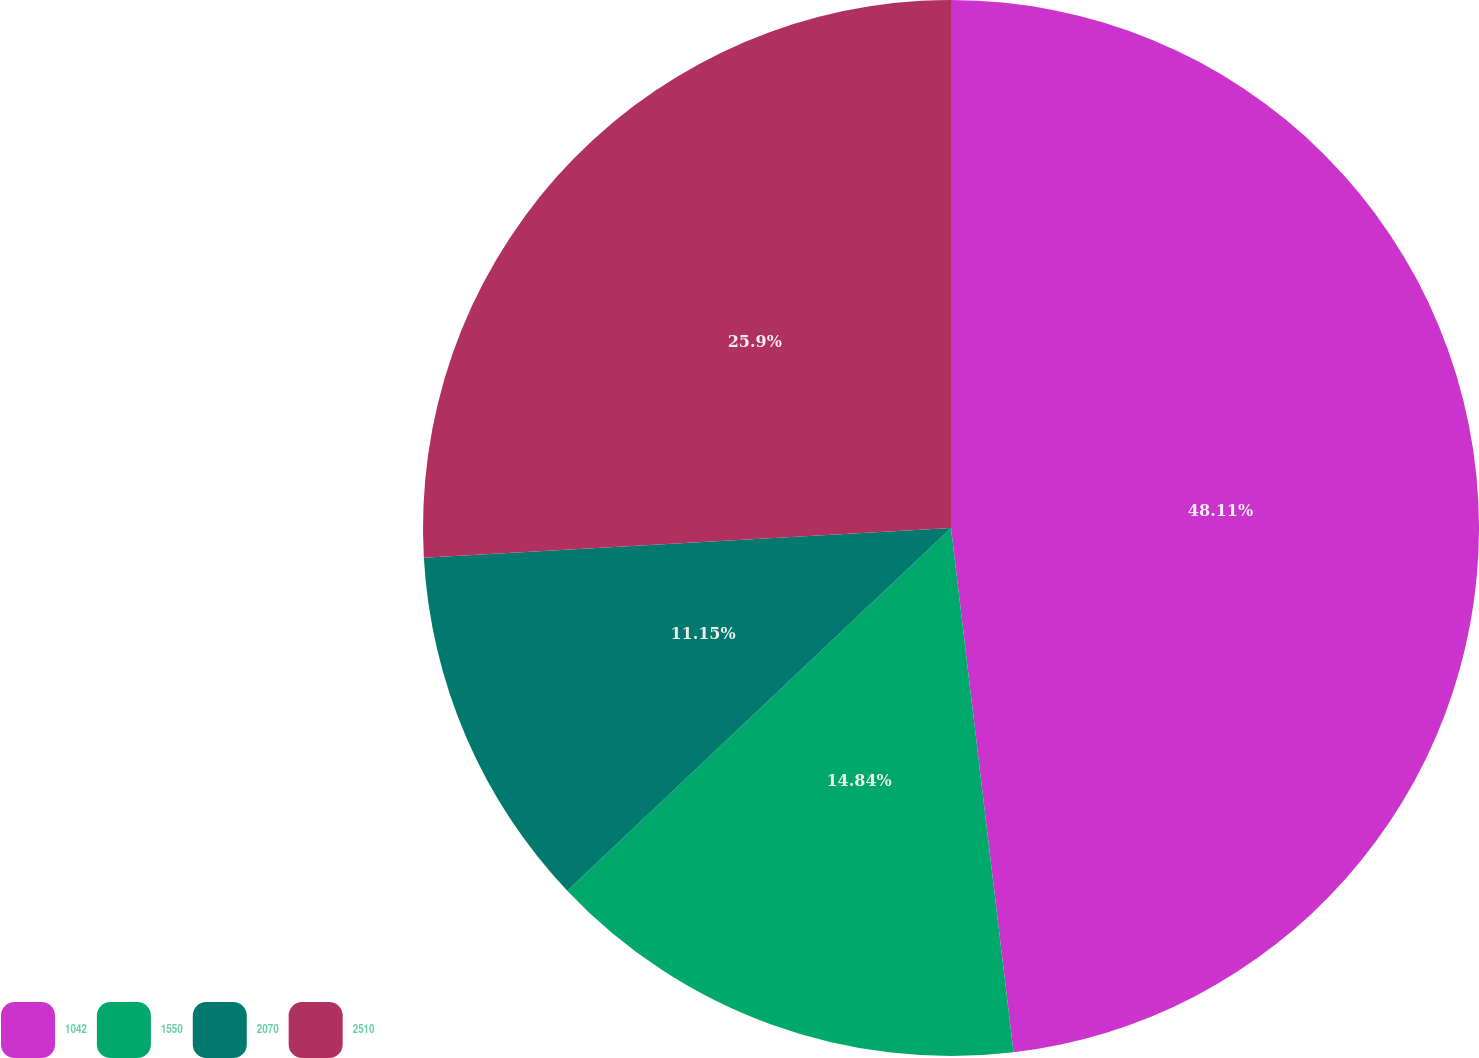Convert chart to OTSL. <chart><loc_0><loc_0><loc_500><loc_500><pie_chart><fcel>1042<fcel>1550<fcel>2070<fcel>2510<nl><fcel>48.11%<fcel>14.84%<fcel>11.15%<fcel>25.9%<nl></chart> 